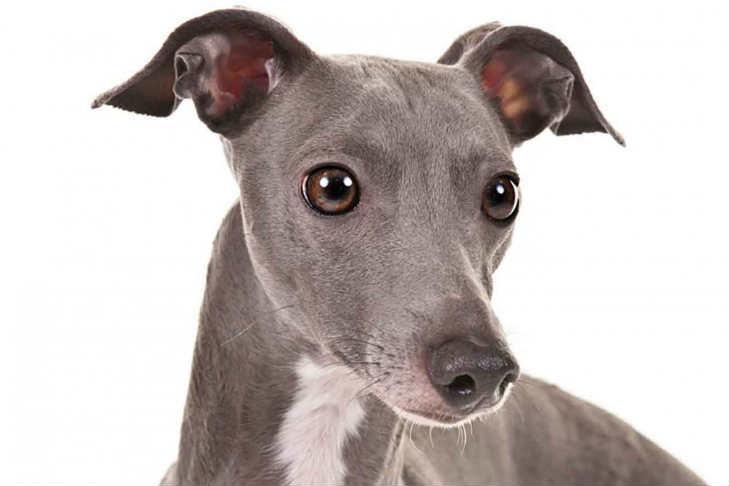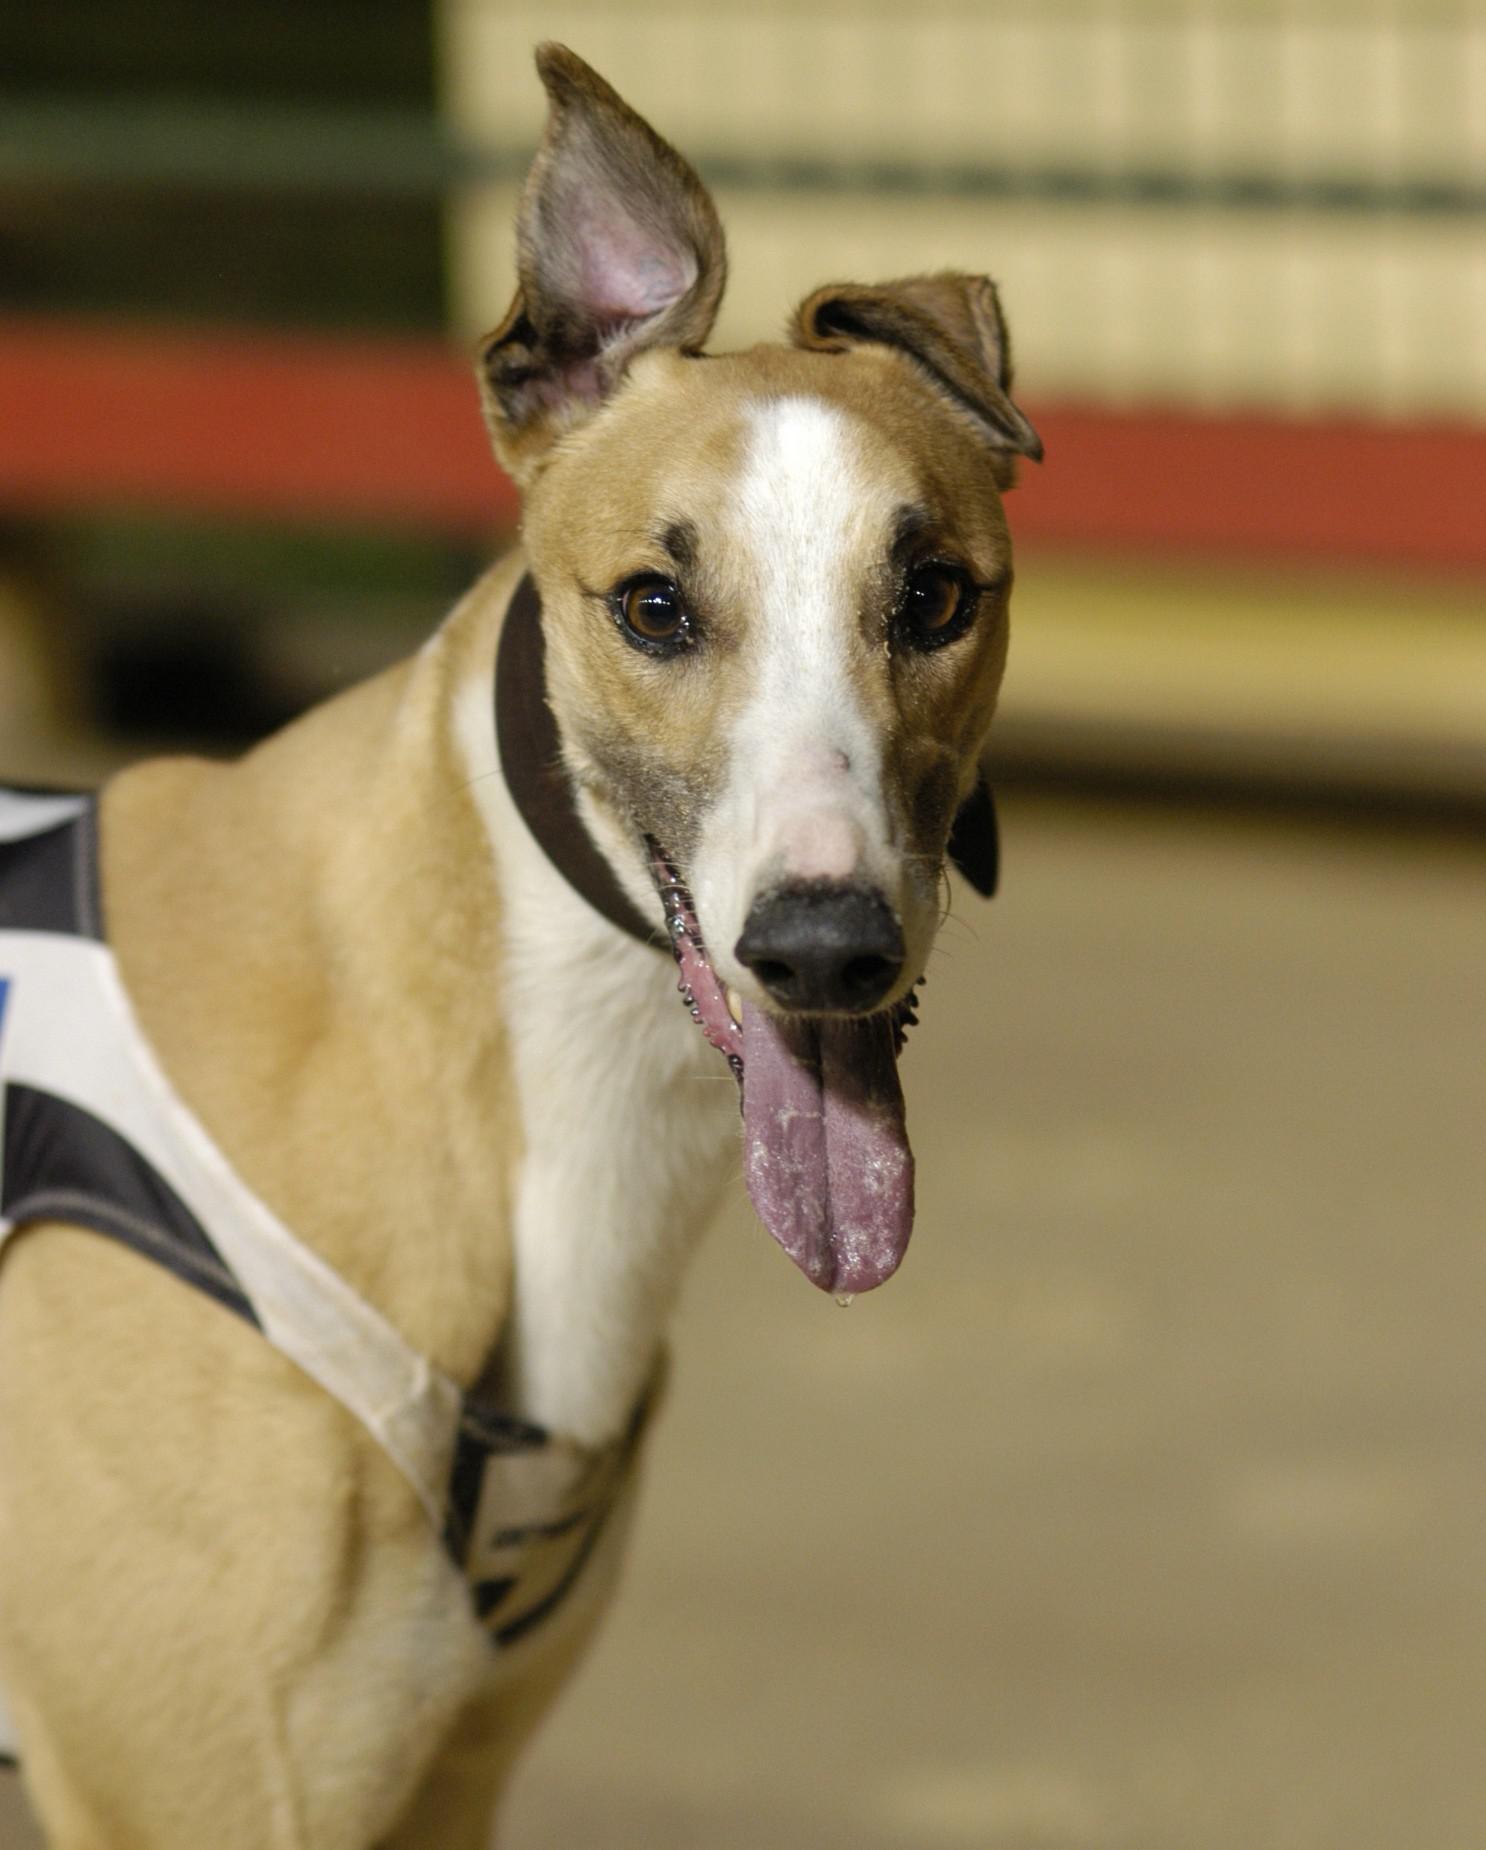The first image is the image on the left, the second image is the image on the right. Evaluate the accuracy of this statement regarding the images: "The dog in the image on the left is wearing a collar.". Is it true? Answer yes or no. No. 